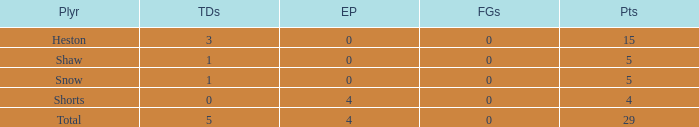What is the total number of field goals a player had when there were more than 0 extra points and there were 5 touchdowns? 1.0. 